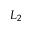Convert formula to latex. <formula><loc_0><loc_0><loc_500><loc_500>L _ { 2 }</formula> 